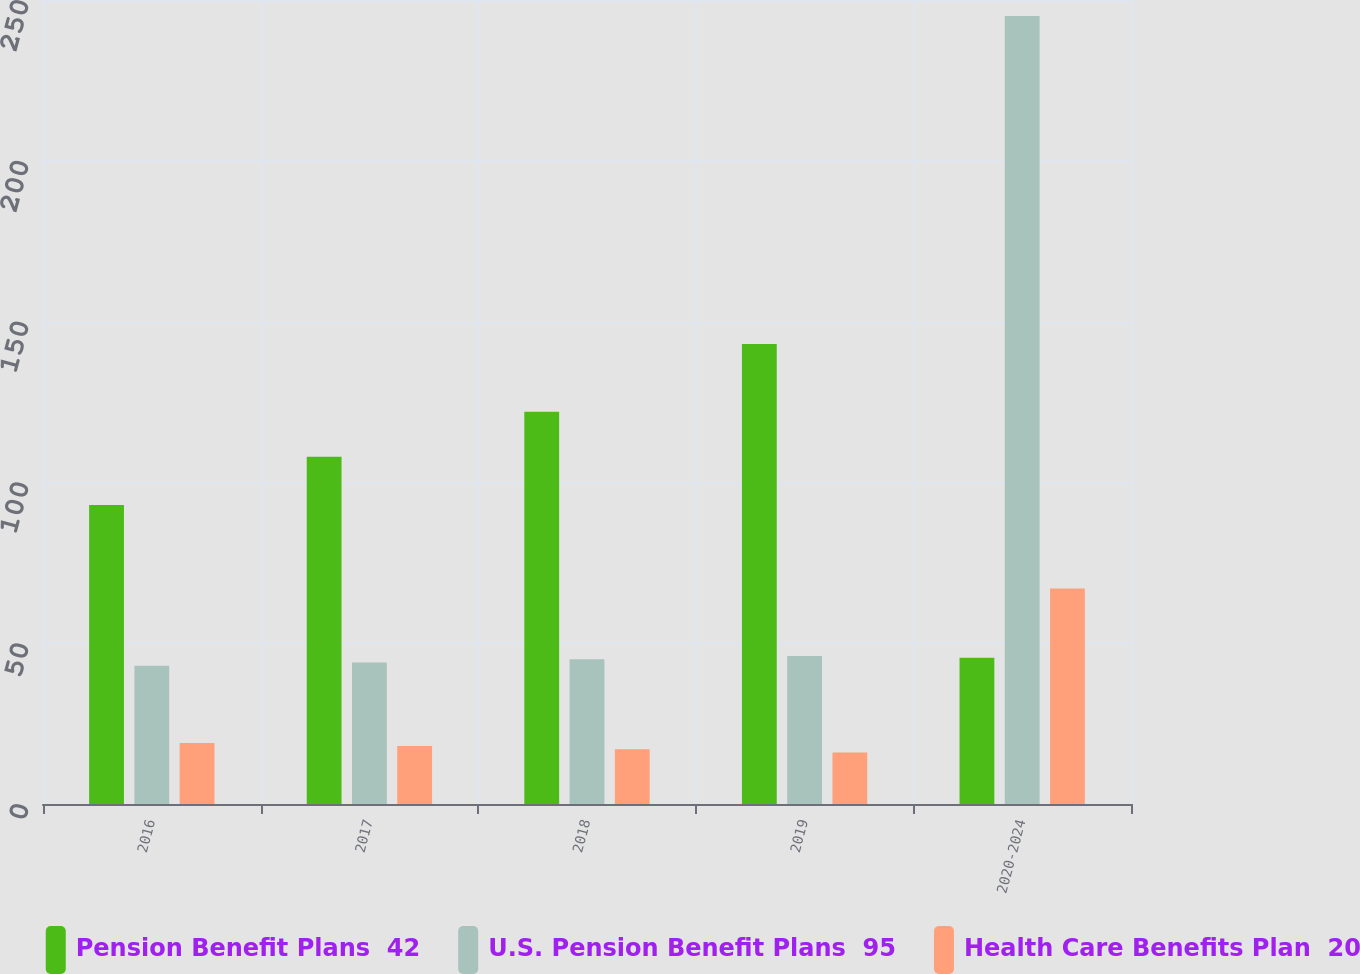Convert chart. <chart><loc_0><loc_0><loc_500><loc_500><stacked_bar_chart><ecel><fcel>2016<fcel>2017<fcel>2018<fcel>2019<fcel>2020-2024<nl><fcel>Pension Benefit Plans  42<fcel>93<fcel>108<fcel>122<fcel>143<fcel>45.5<nl><fcel>U.S. Pension Benefit Plans  95<fcel>43<fcel>44<fcel>45<fcel>46<fcel>245<nl><fcel>Health Care Benefits Plan  20<fcel>19<fcel>18<fcel>17<fcel>16<fcel>67<nl></chart> 